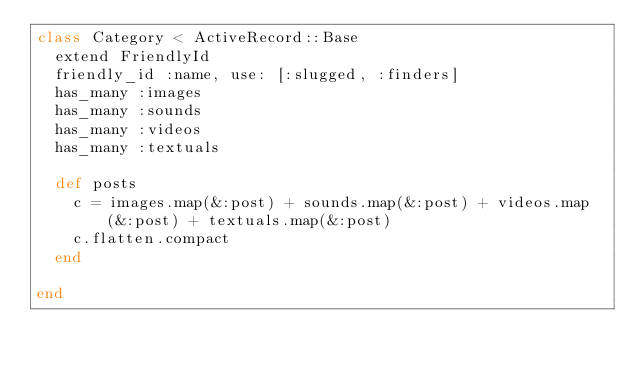<code> <loc_0><loc_0><loc_500><loc_500><_Ruby_>class Category < ActiveRecord::Base
  extend FriendlyId
  friendly_id :name, use: [:slugged, :finders]
  has_many :images
  has_many :sounds
  has_many :videos
  has_many :textuals

  def posts
    c = images.map(&:post) + sounds.map(&:post) + videos.map(&:post) + textuals.map(&:post)
    c.flatten.compact
  end
  
end
</code> 